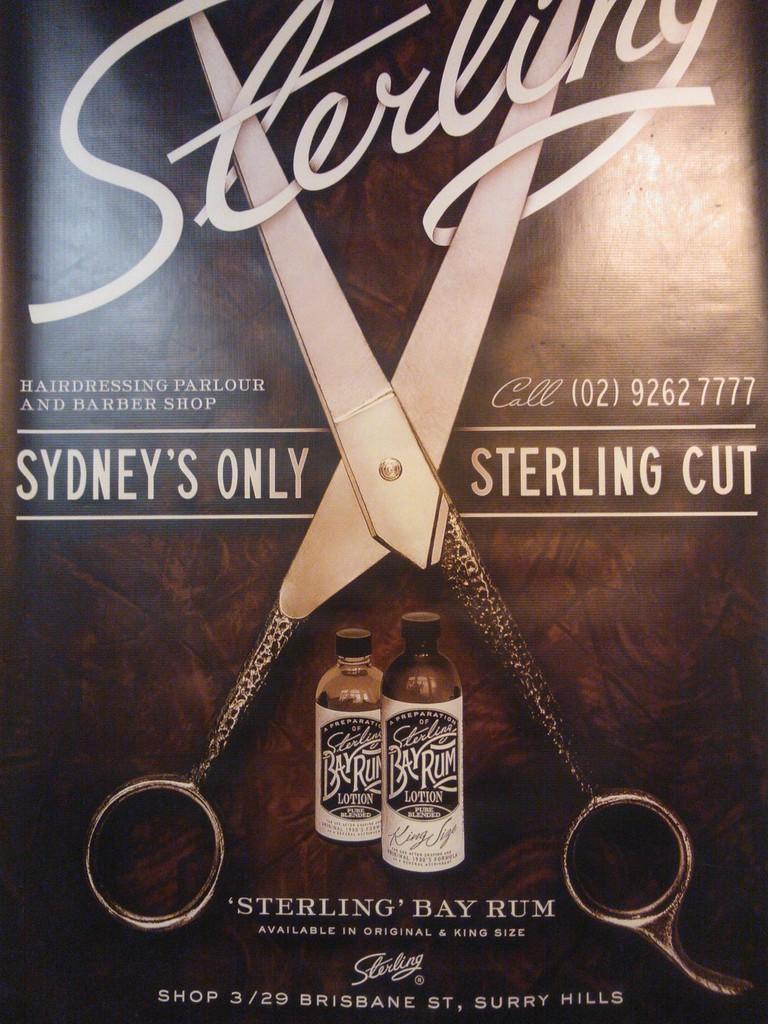Where is the shop located on this ad?
Your answer should be very brief. Surry hills. What phone number is listed on the ad?
Give a very brief answer. 02 9262 7777. 